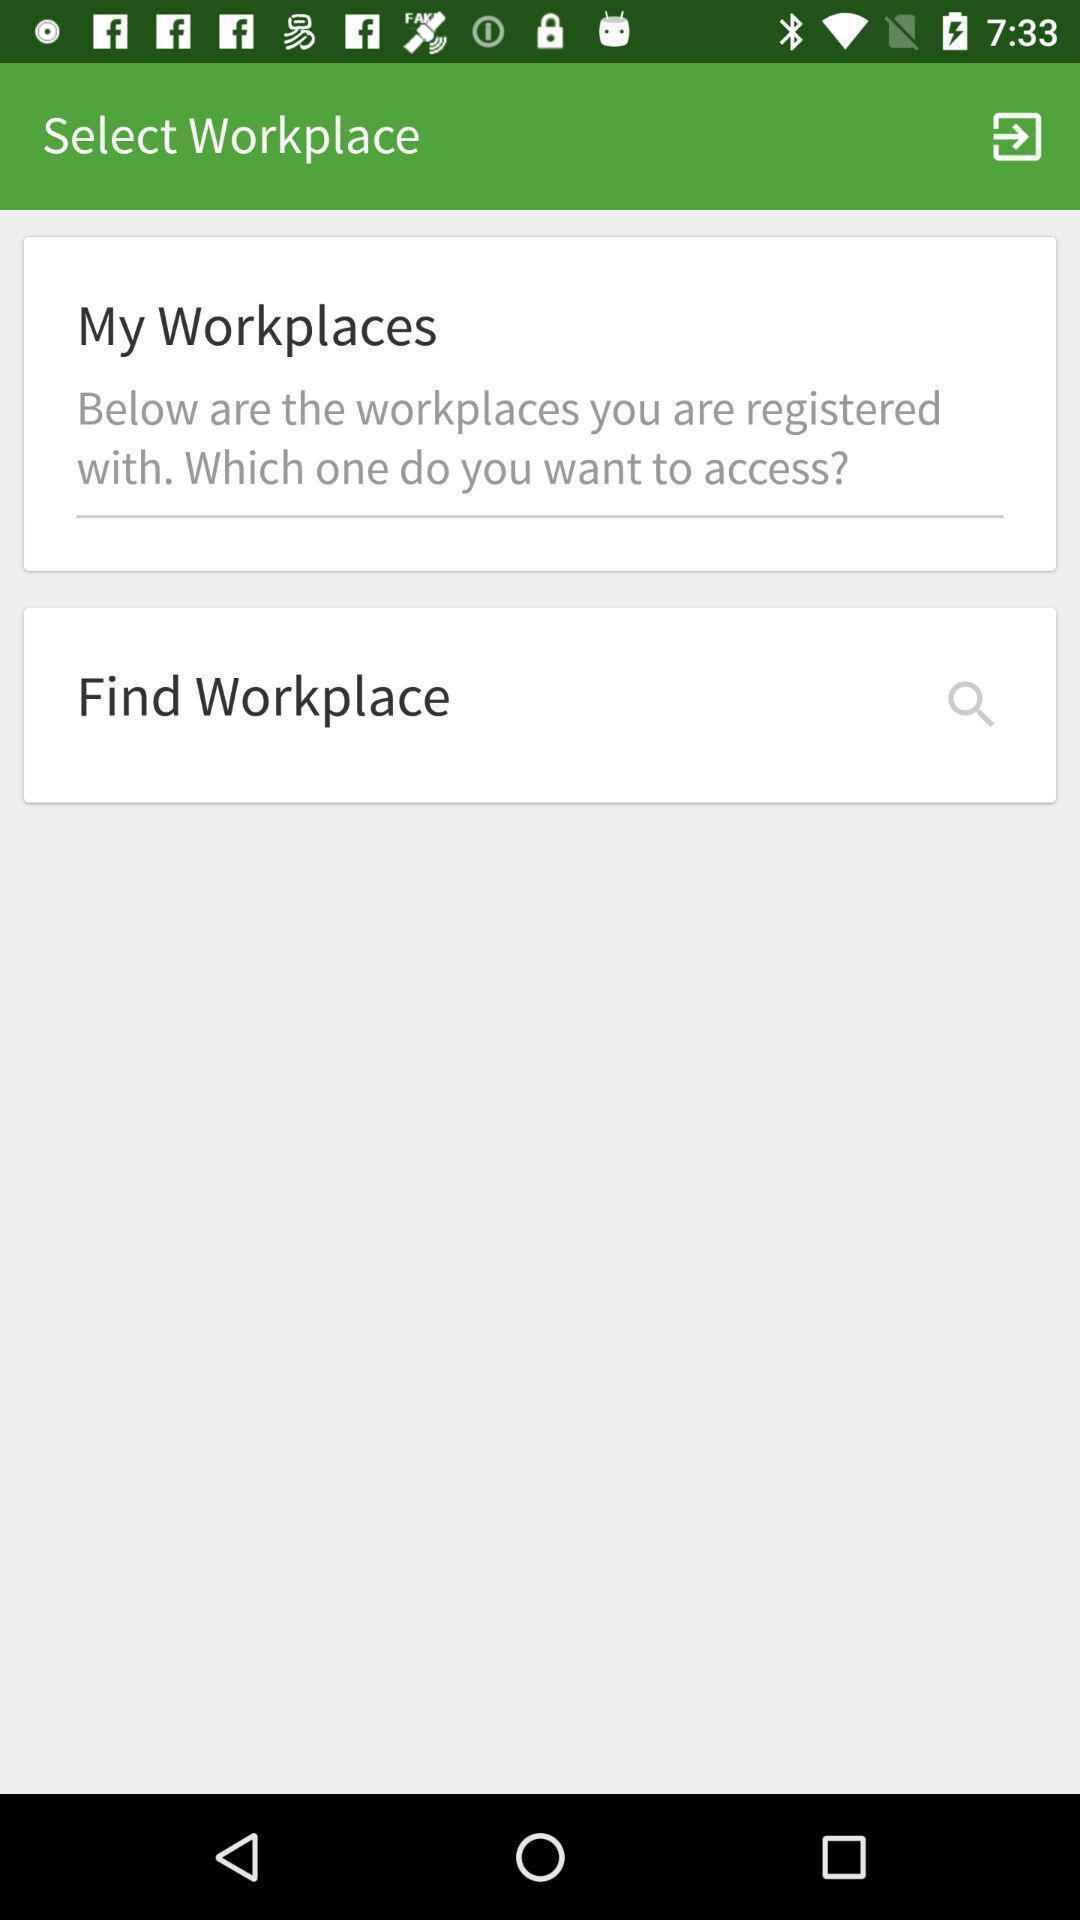Describe the visual elements of this screenshot. Page showing information. 